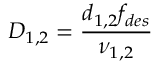Convert formula to latex. <formula><loc_0><loc_0><loc_500><loc_500>D _ { 1 , 2 } = \frac { d _ { 1 , 2 } f _ { d e s } } { \nu _ { 1 , 2 } }</formula> 